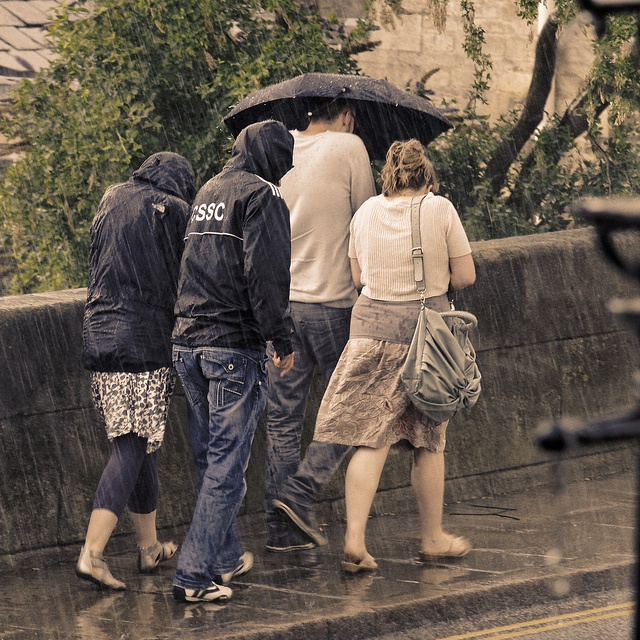Describe the objects in this image and their specific colors. I can see people in gray and black tones, people in gray and tan tones, people in gray and black tones, people in gray, black, and tan tones, and umbrella in gray and black tones in this image. 